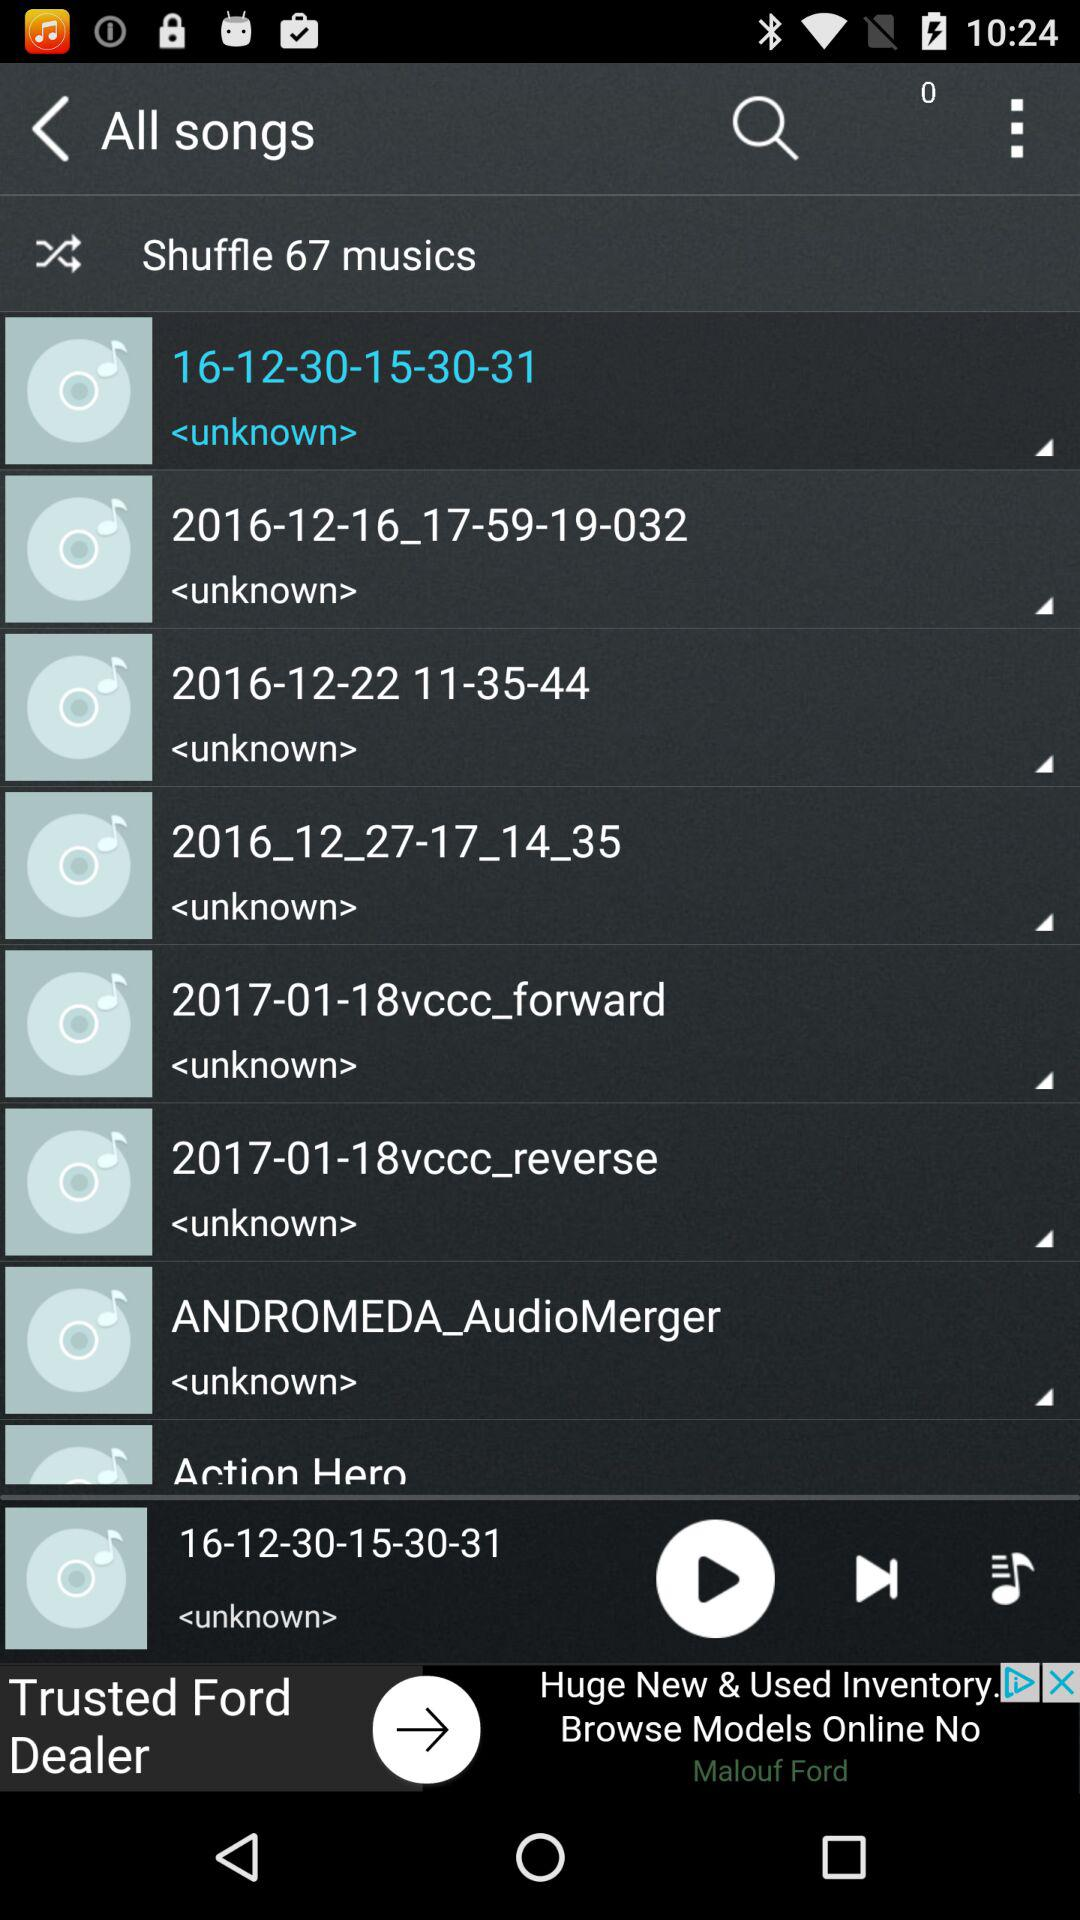Which music is playing on the screen? The music that is playing on the screen is 16-12-30-15-30-31. 